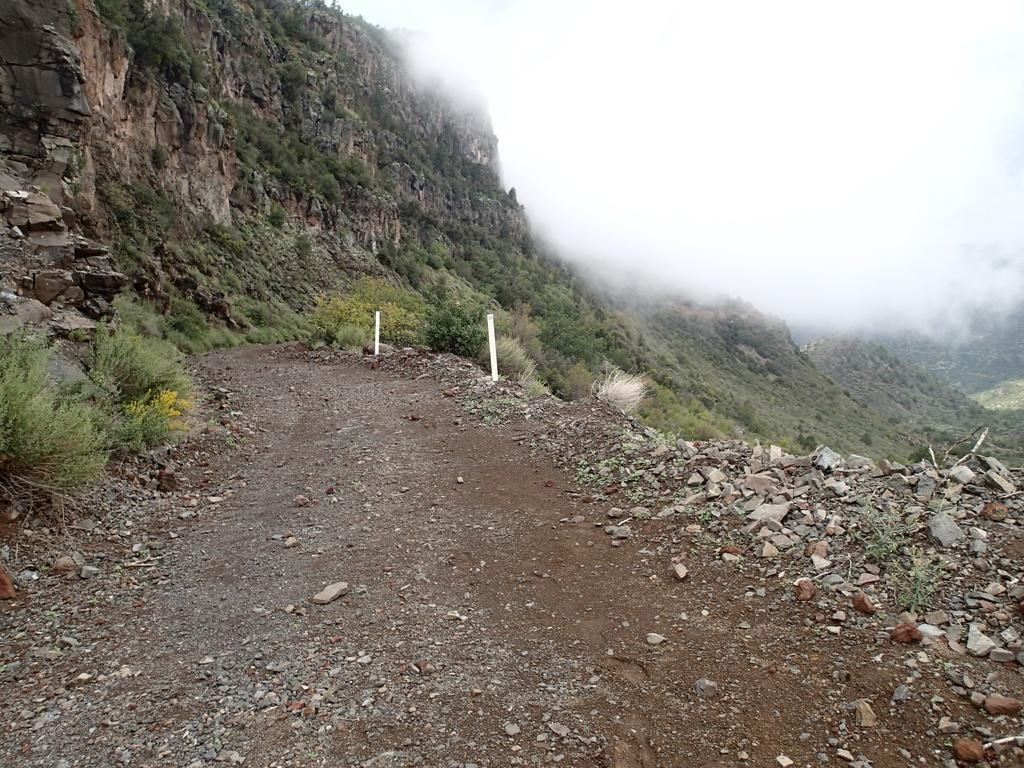What type of natural elements can be seen in the image? There are stones and grass in the image. What geological feature is present in the image? There are rock mountains in the image. Are there any man-made structures visible in the image? Yes, there are two poles in the image. What type of lace can be seen on the channel in the image? There is no channel or lace present in the image. What kind of art is displayed on the rock mountains in the image? There is no art displayed on the rock mountains in the image; they are natural geological formations. 